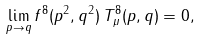<formula> <loc_0><loc_0><loc_500><loc_500>\lim _ { p \rightarrow q } f ^ { 8 } ( p ^ { 2 } , q ^ { 2 } ) \, T _ { \mu } ^ { 8 } ( p , q ) = 0 ,</formula> 